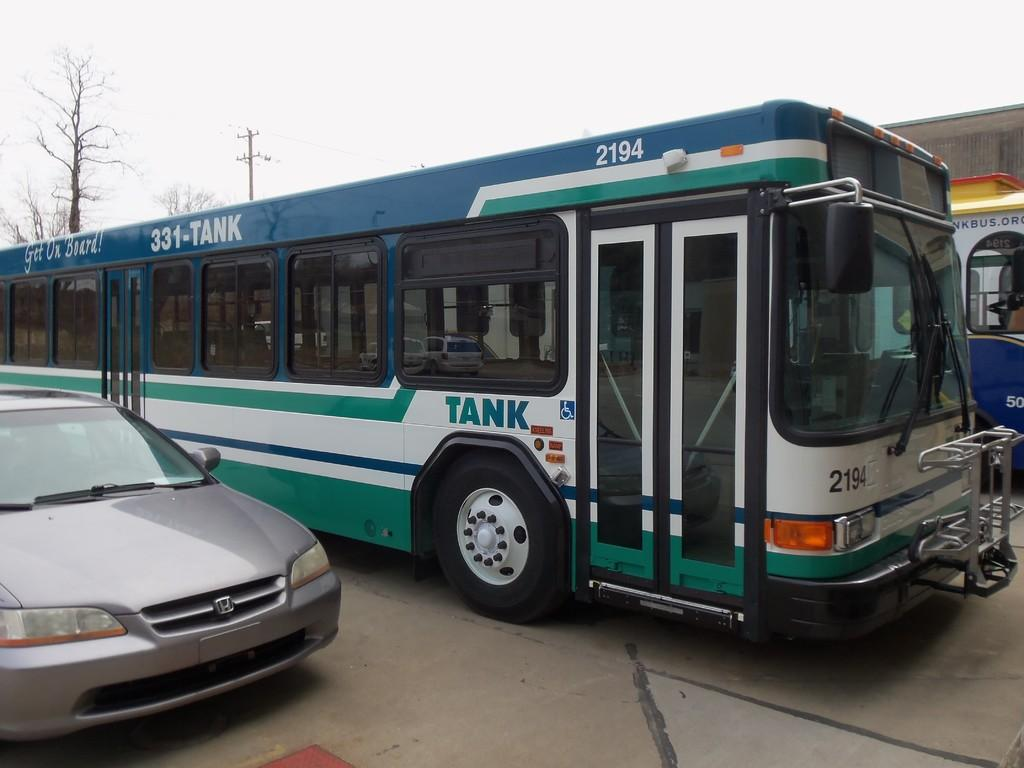What type of objects are on the ground in the image? There are vehicles on the ground in the image. What natural elements can be seen in the image? Trees are visible in the image. What man-made structure is present in the image? There is an utility pole in the image. What type of building is in the image? There is a building in the image. What is the condition of the sky in the image? The sky is visible in the image, and it appears cloudy. What type of straw is being used to channel water in the image? There is no straw or water channeling activity present in the image. What type of earth can be seen in the image? The image does not show any specific type of earth; it features vehicles, trees, an utility pole, a building, and a cloudy sky. 